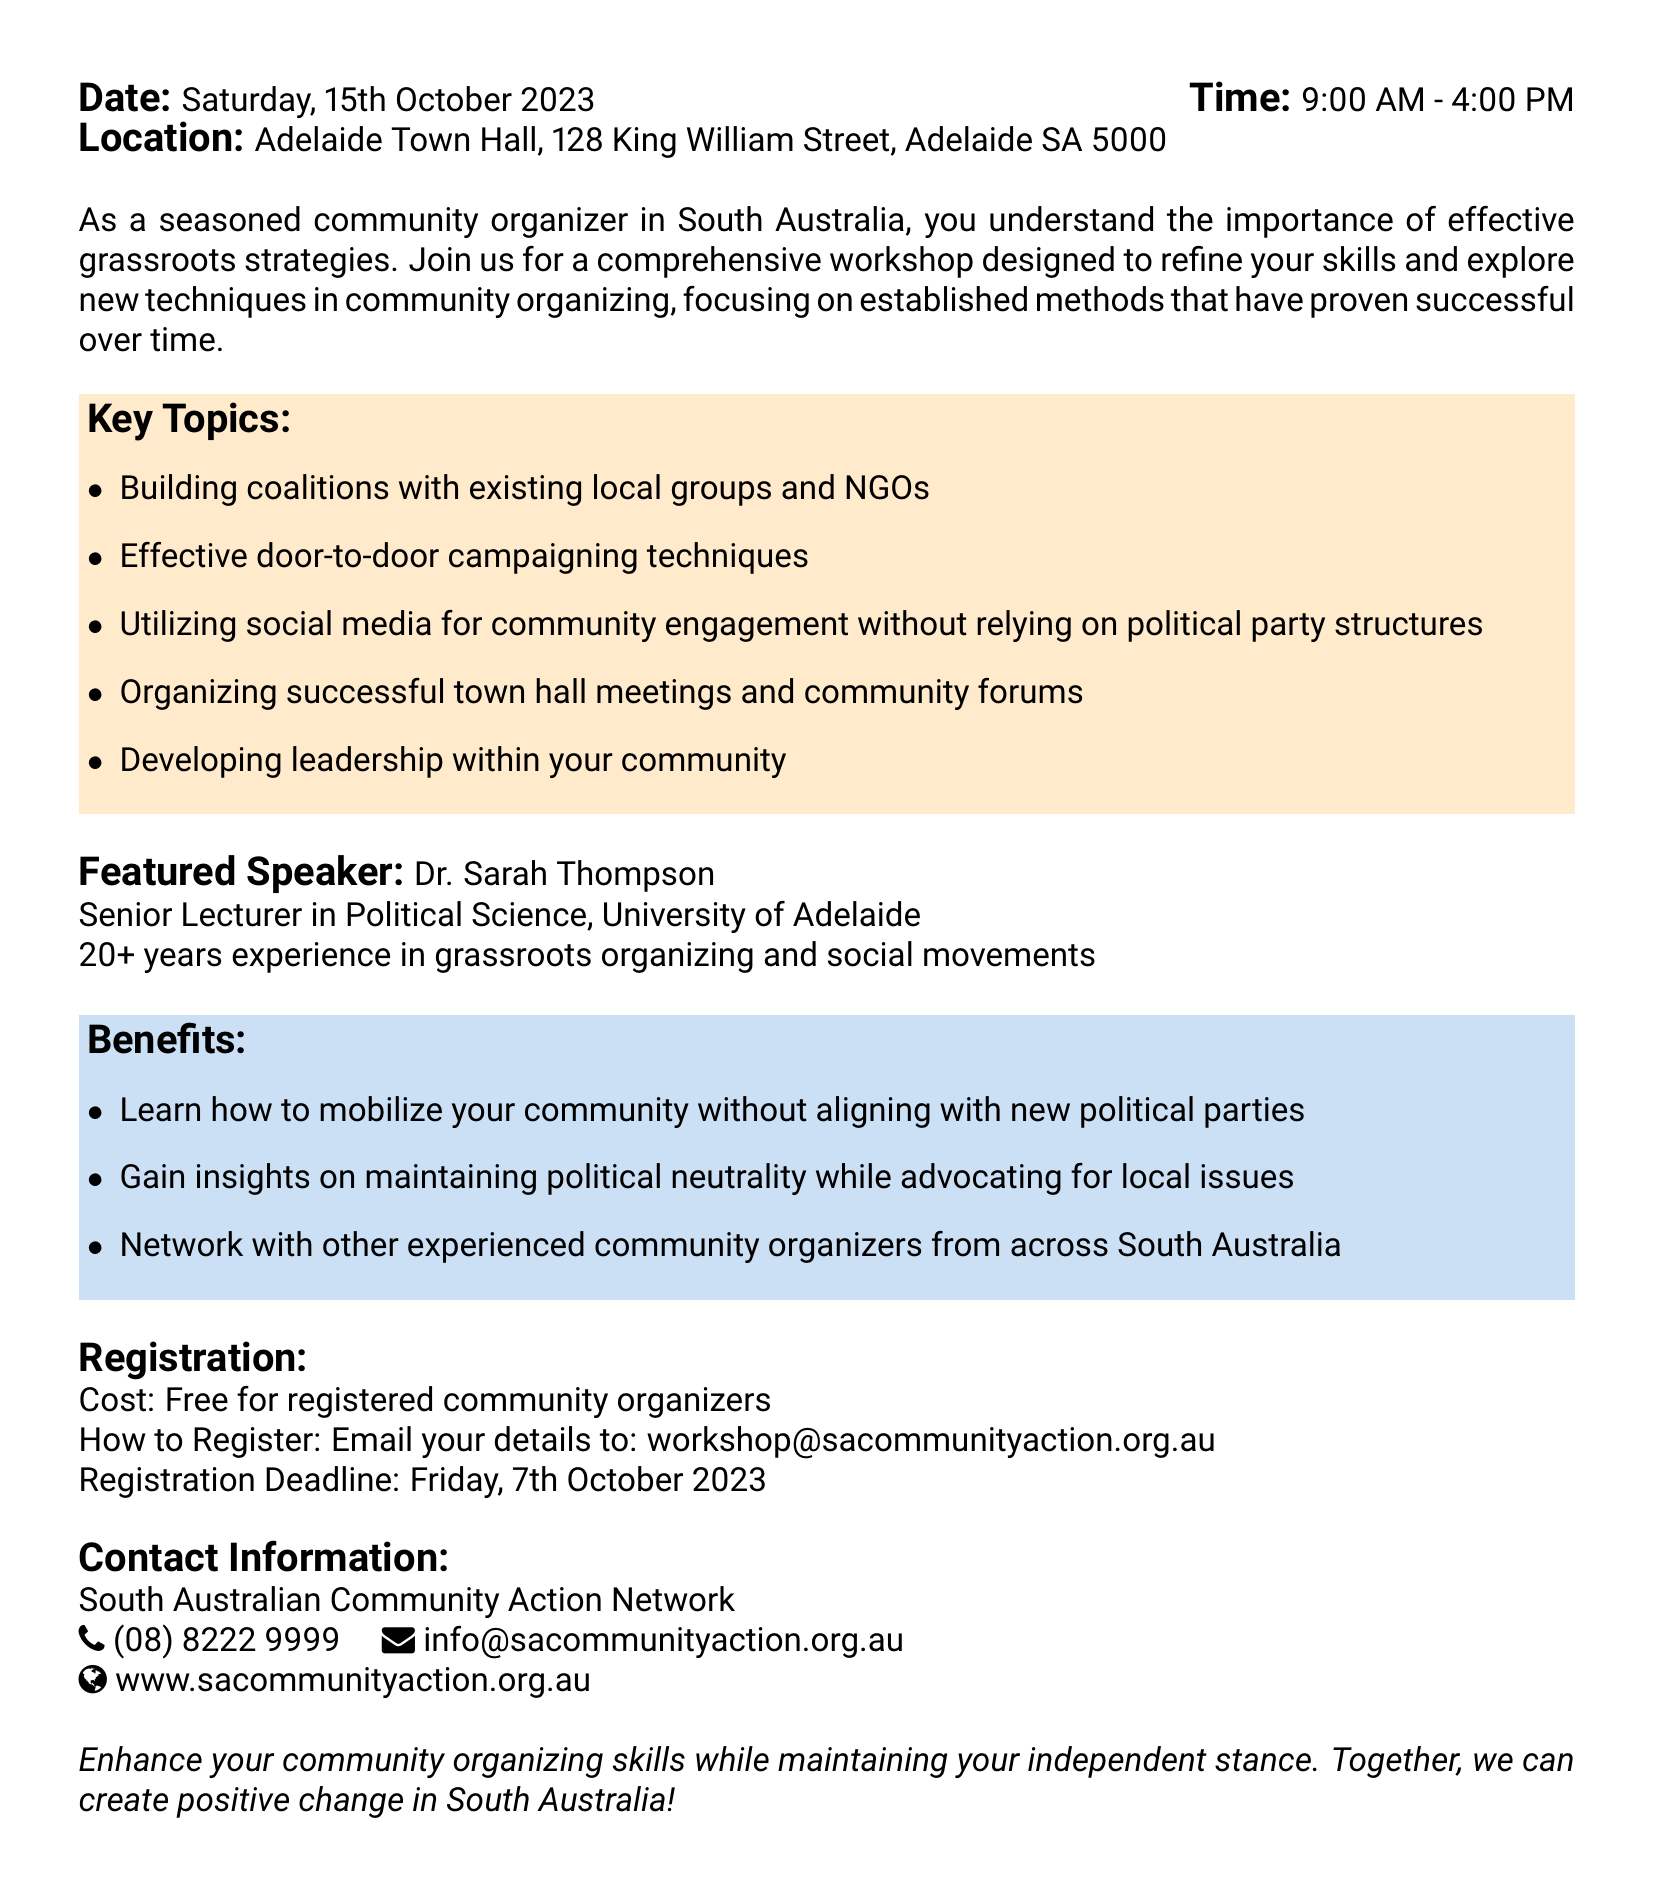What is the title of the workshop? The title is prominently mentioned at the top of the document.
Answer: Community Organizing Mastery Workshop Who is the featured speaker? The speaker's name and credentials are highlighted in the document.
Answer: Dr. Sarah Thompson What is the date of the workshop? The date is clearly presented in the header section of the document.
Answer: Saturday, 15th October 2023 What are attendees learning to do without aligning with new political parties? This information is provided in the benefits section of the document.
Answer: Mobilize the community What is the registration deadline? The registration deadline is specified in the registration section of the document.
Answer: Friday, 7th October 2023 What type of location is the workshop being held at? The location is stated in the header, indicating a specific venue type.
Answer: Town Hall How long is the workshop scheduled to last? The duration is indicated alongside the time information in the header.
Answer: 7 hours What is the cost for registered community organizers? The cost information is presented in the registration section of the document.
Answer: Free What is one of the key topics covered in the workshop? The key topics are listed with bullet points in the document.
Answer: Building coalitions with existing local groups and NGOs 